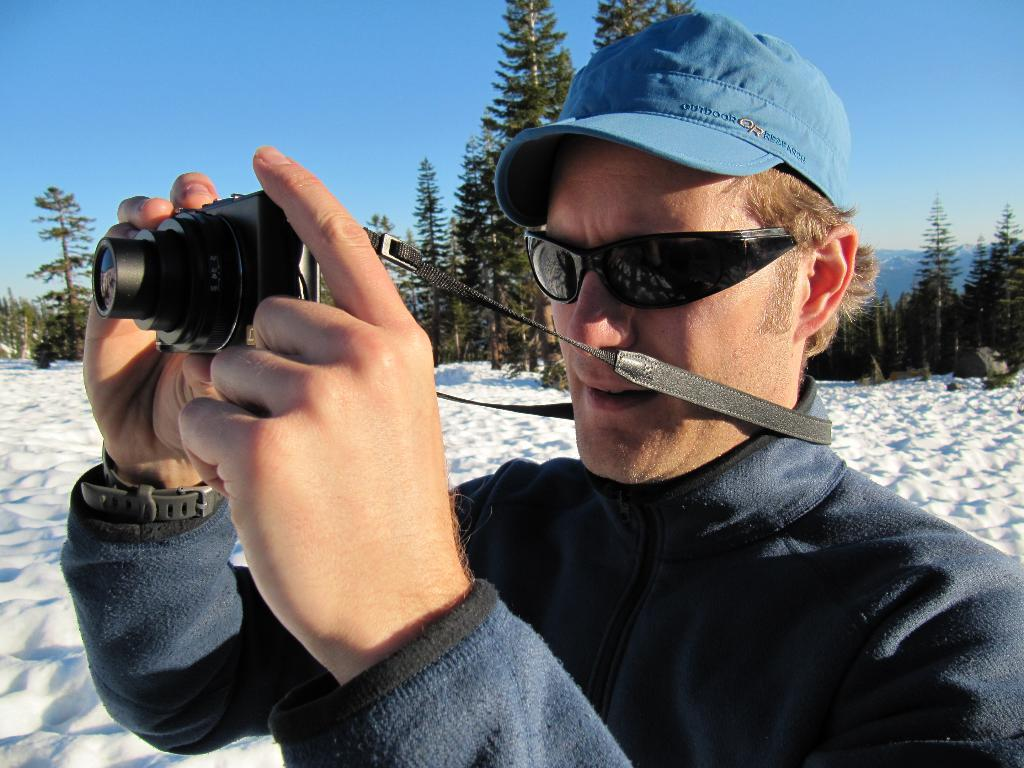What is the person in the image doing? The person in the image is holding a camera. What can be seen in the background of the image? There is sky visible in the image, as well as trees. What is the weather like in the image? The presence of snow in the image suggests that it is a snowy environment. What type of drug is being used by the person in the image? There is no indication of any drug use in the image; the person is simply holding a camera. 